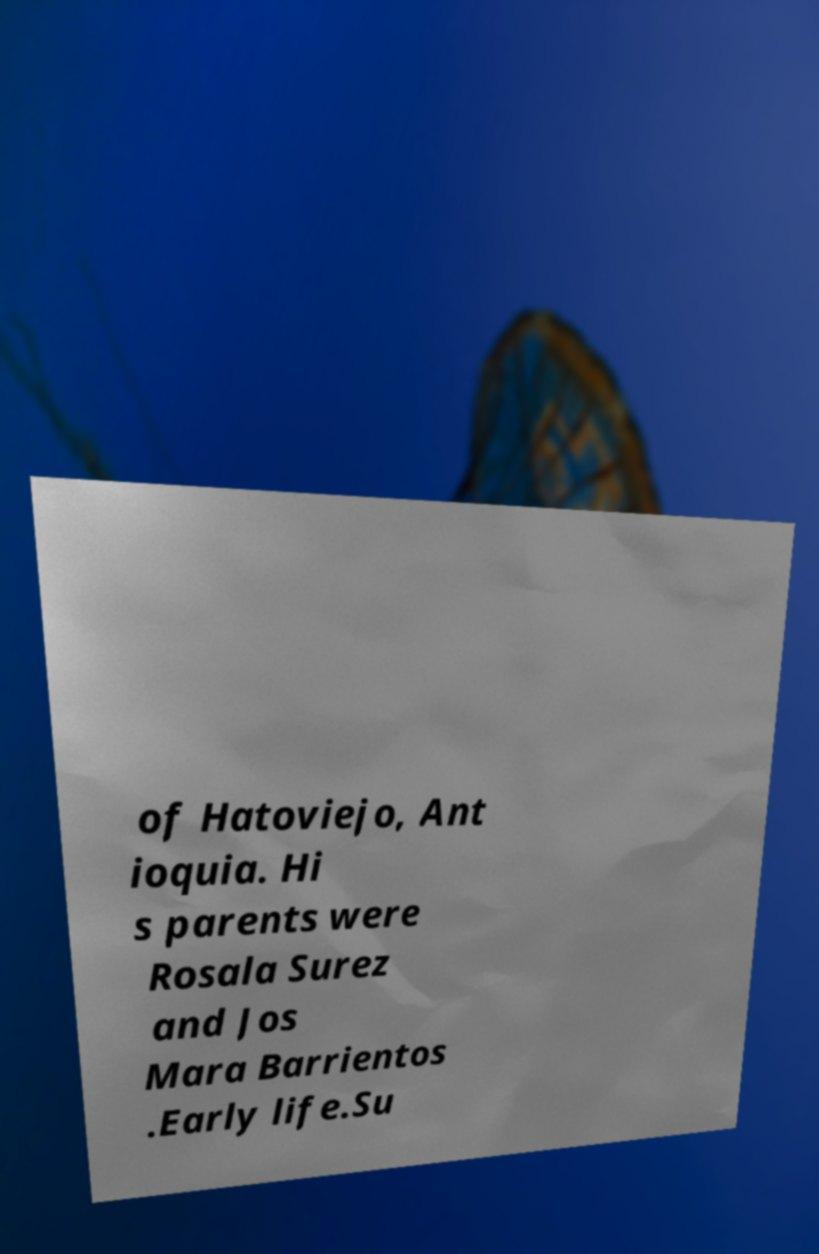Could you assist in decoding the text presented in this image and type it out clearly? of Hatoviejo, Ant ioquia. Hi s parents were Rosala Surez and Jos Mara Barrientos .Early life.Su 